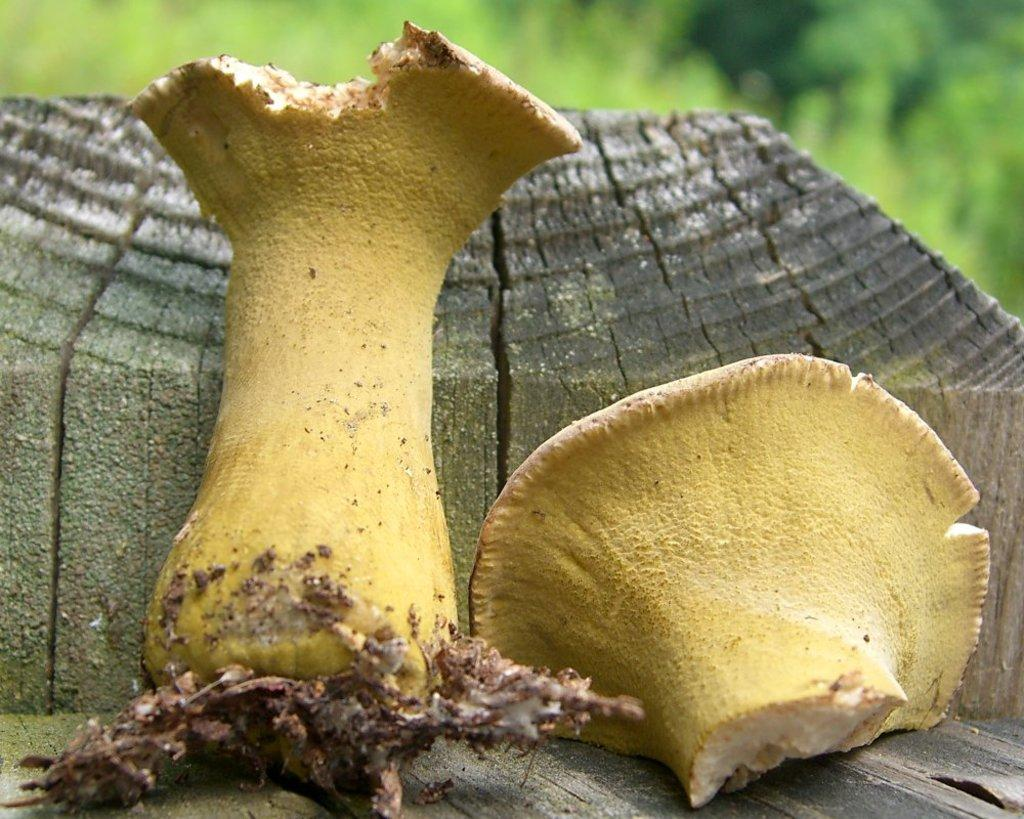What type of food is shown in the image? There are mushroom pieces in the image. On what surface are the mushroom pieces placed? The mushroom pieces are on a wood surface. What other material is present with the mushroom pieces? Soil is present with the mushroom pieces. How would you describe the background of the image? The background is green and blurred. What type of soap is being used to clean the mushroom pieces in the image? There is no soap present in the image, and the mushroom pieces are not being cleaned. 